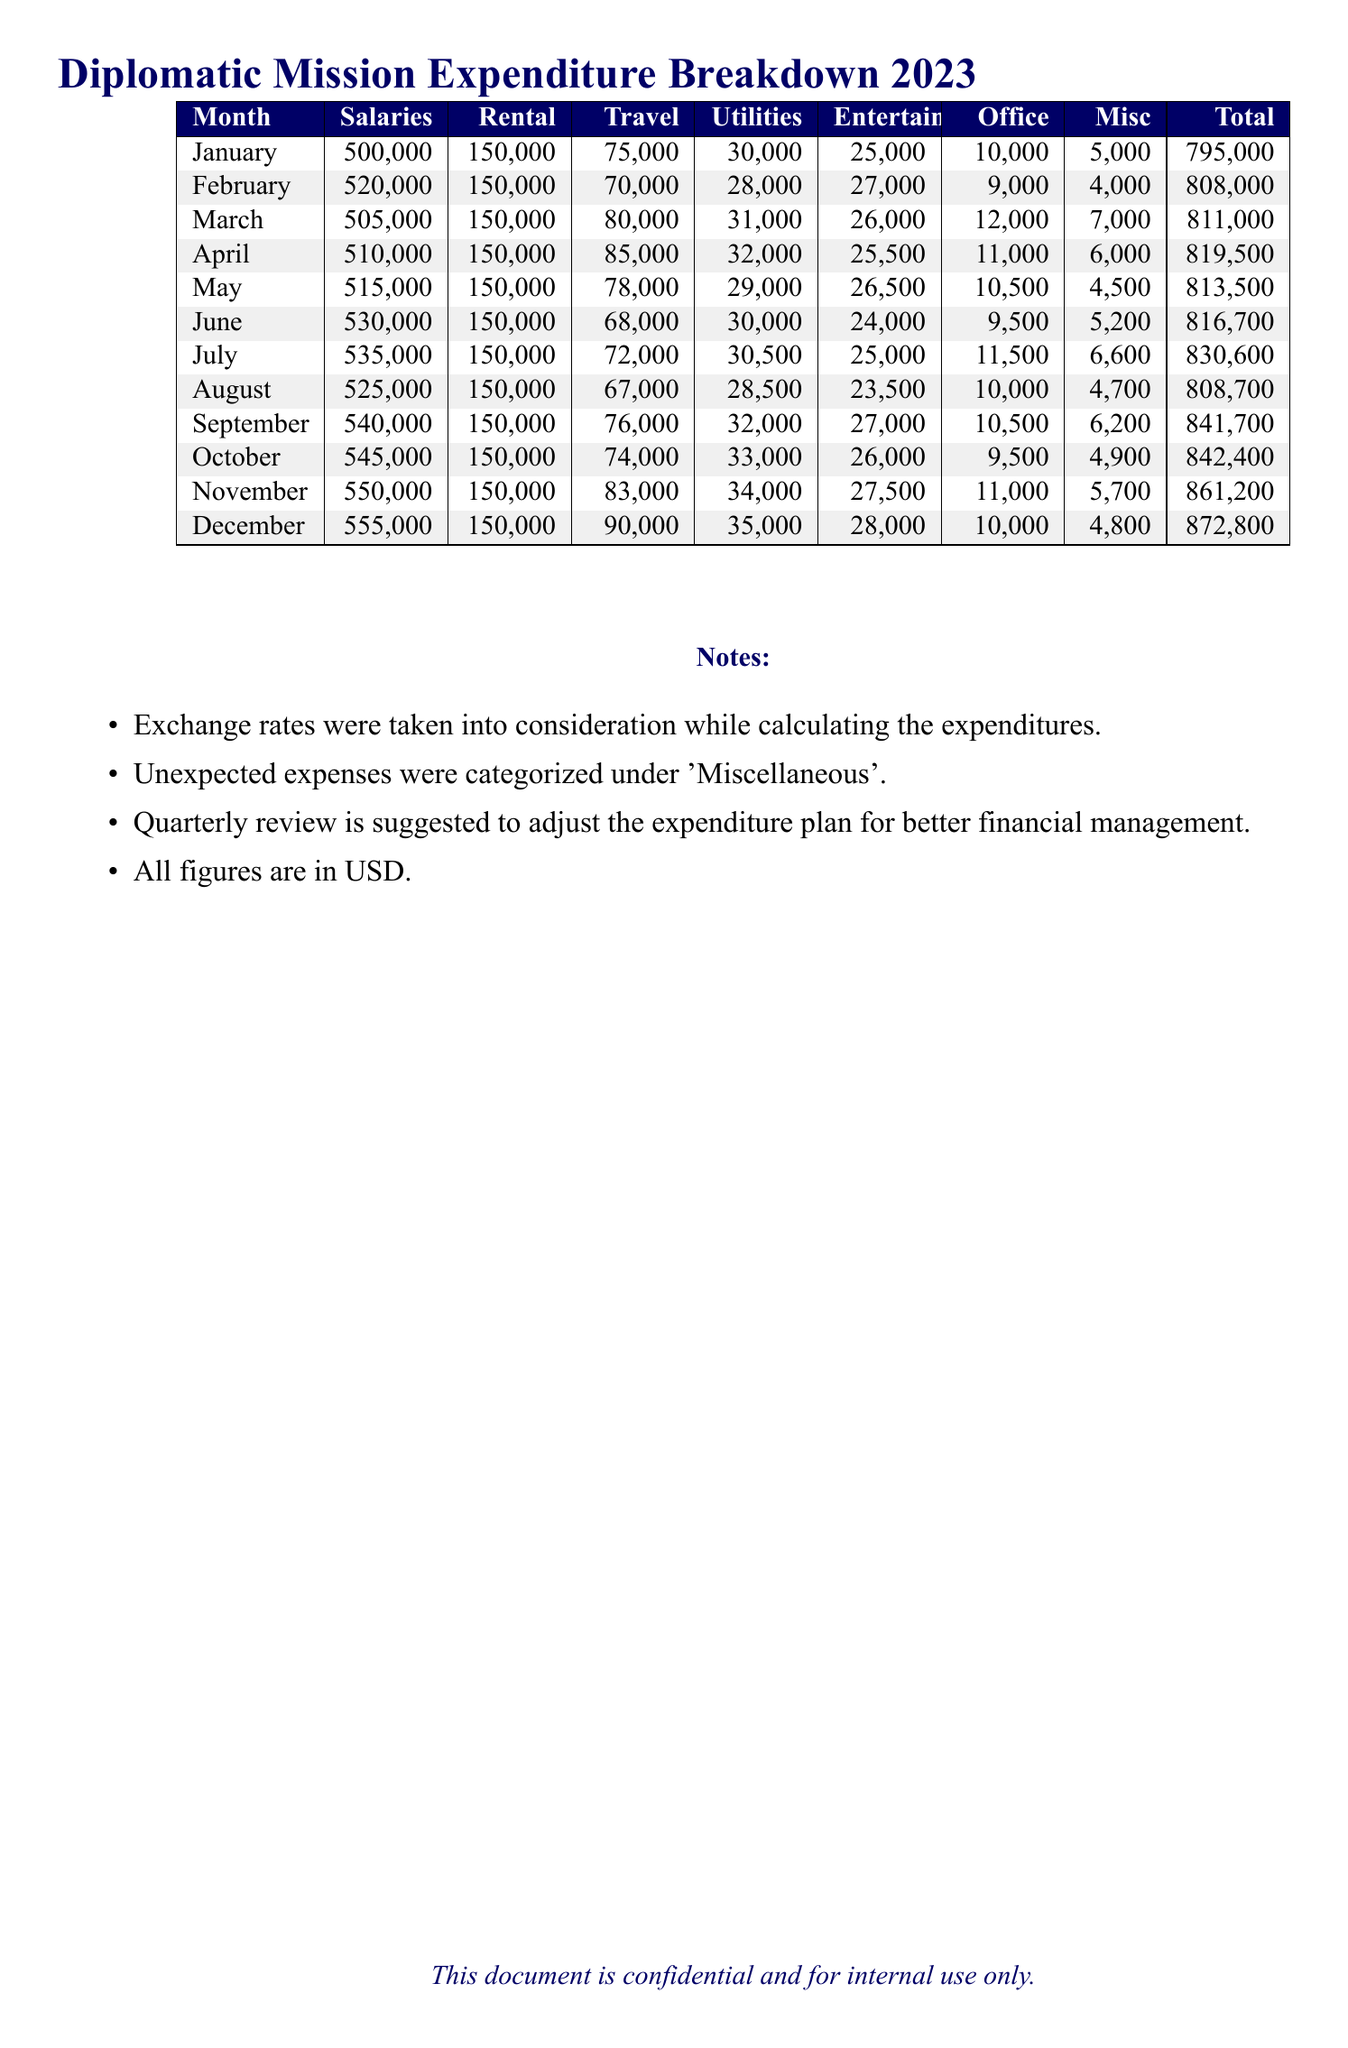What is the total expenditure for December? The total expenditure for December is stated in the document under the total column.
Answer: 872,800 Which month had the highest salary expenditure? The highest salary expenditure can be found by comparing the salaries for each month in the table.
Answer: December What is the amount spent on travel in July? The amount spent on travel in July is indicated in the corresponding row of the table.
Answer: 72,000 How much was spent on utilities in March? The amount for utilities in March can be retrieved from the document where it lists the expenditures by month.
Answer: 31,000 What is the average total expenditure for the first quarter (January to March)? The average is calculated by summing the total expenditures for these months and dividing by three.
Answer: 804,333.33 What percentage of the total expenditure for November was due to salaries? The calculation would be based on the salaries and total expenditure for that month, as shown in the document.
Answer: 63.96% How much was spent on miscellaneous in April? The miscellaneous expenditure for April is listed specifically in the document.
Answer: 6,000 Which month experienced a drop in travel expenditure compared to the previous month? By examining the travel expenditures for consecutive months, one can find where a decrease occurred.
Answer: June What category of expenditure is considered unexpected? The document categorizes unexpected expenses specifically under one heading.
Answer: Miscellaneous 